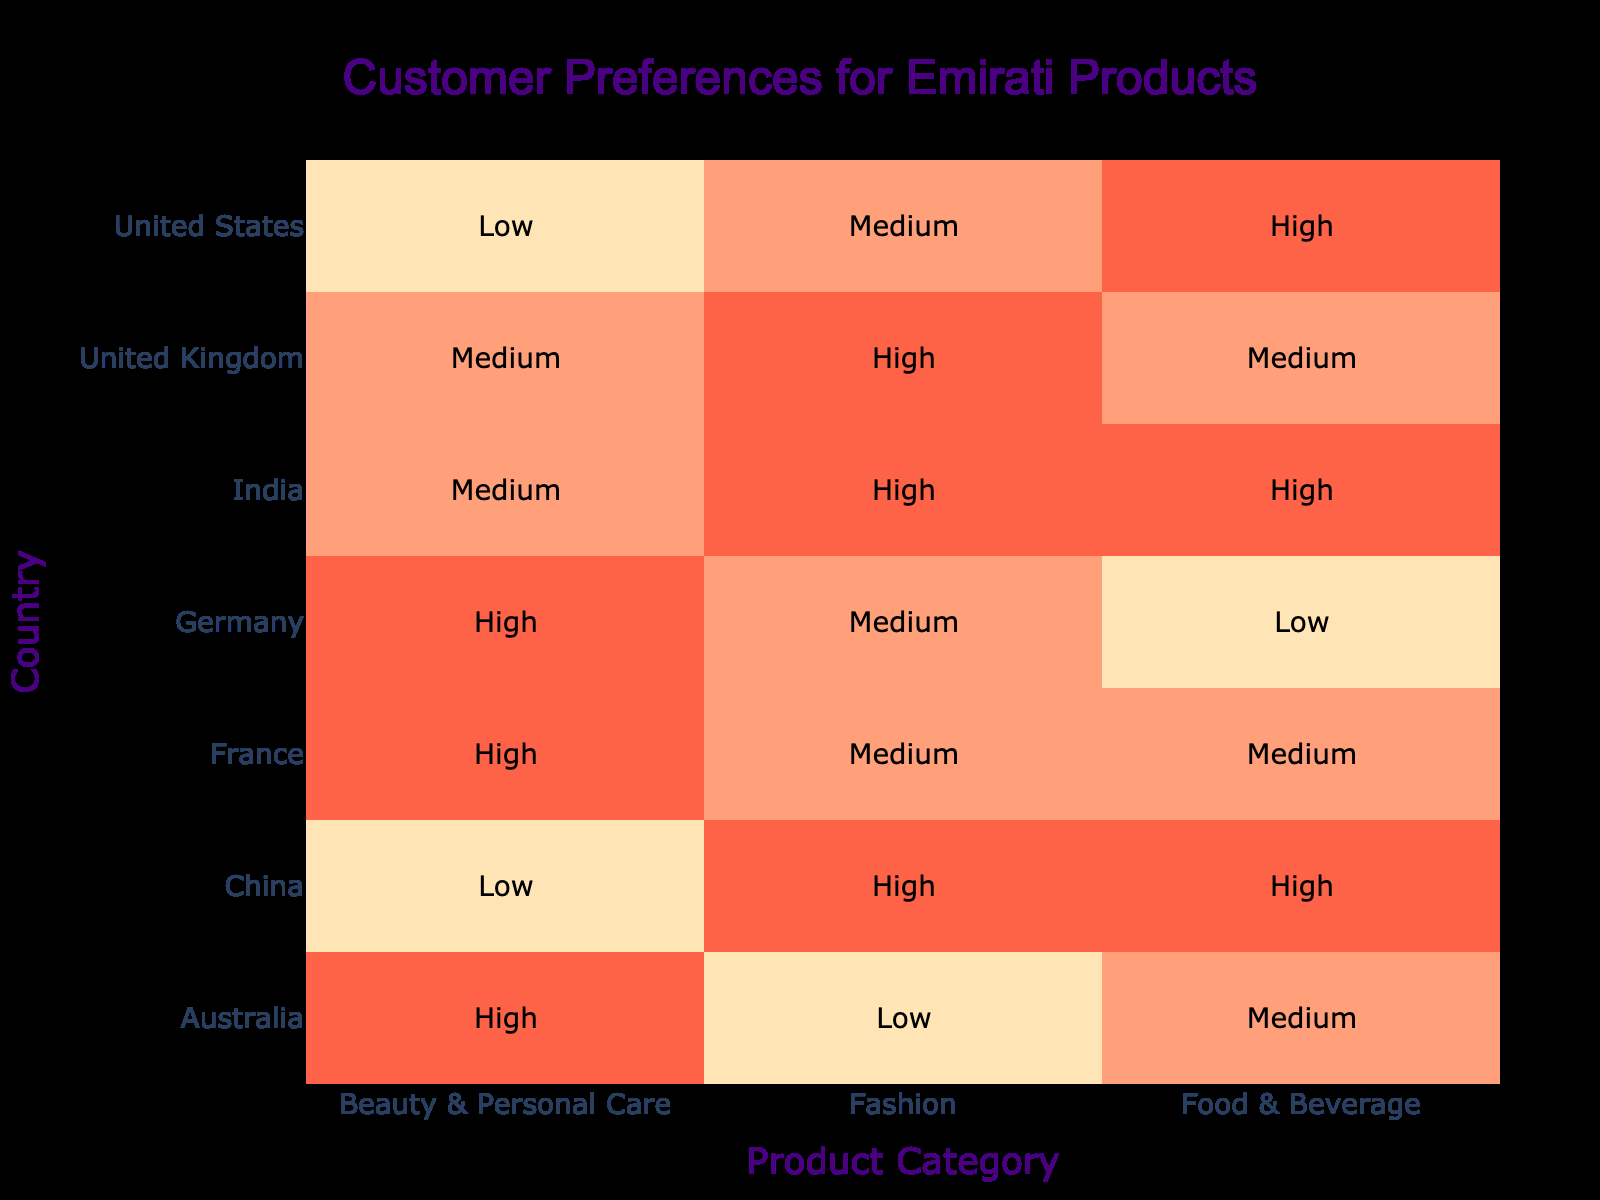What is the highest preference level for Food & Beverage among the countries listed? By examining the 'Food & Beverage' row across all countries, the highest preference level found is 'High' in the United States, India, and China.
Answer: High Which country shows a preference for Beauty & Personal Care as 'Low'? Looking at the 'Beauty & Personal Care' column, the only country with a preference level of 'Low' is China.
Answer: China Count the number of countries that prefer Fashion as 'High'. By checking the 'Fashion' column, we find that the countries with a 'High' preference are the United Kingdom, India, and China, giving a total count of 3.
Answer: 3 Is there any country that has a 'Low' preference for more than one product category? From the table, Germany has a 'Low' preference for Food & Beverage, and Australia has a 'Low' preference for Fashion. Therefore, yes, they both have a 'Low' category but only in one respective product. Thus, there's no country with 'Low' preference in multiple product categories.
Answer: No What is the difference in the number of countries showing 'High' preference for Fashion versus those showing 'High' preference for Beauty & Personal Care? The countries with 'High' preference for Fashion are the United Kingdom, India, and China (total = 3), while for Beauty & Personal Care, the countries with 'High' preference are Germany, India, and France (total = 3). Hence, the difference = 3 - 3 = 0.
Answer: 0 In which product category does India have the highest preference level? For India, checking the product categories, both Food & Beverage and Fashion have 'High' preference levels while Beauty & Personal Care has 'Medium'. Therefore, the highest preference level in any category is 'High'.
Answer: Food & Beverage and Fashion What is the overall trend in preference for Food & Beverage across the countries? Analyzing the 'Food & Beverage' column, there are 3 'High', 4 'Medium', and 3 'Low'. This indicates that the preference is moderately distributed but leaning slightly more towards 'High' and 'Medium'.
Answer: Moderate to High Do both Australia and Germany have the same preference level for any product category? By comparing preferences, Australia shows 'Medium' for Food & Beverage, 'Low' for Fashion, and 'High' for Beauty & Personal Care. Germany has 'Low' for Food & Beverage, 'Medium' for Fashion, and 'High' for Beauty & Personal Care. They do not match in any category.
Answer: No 